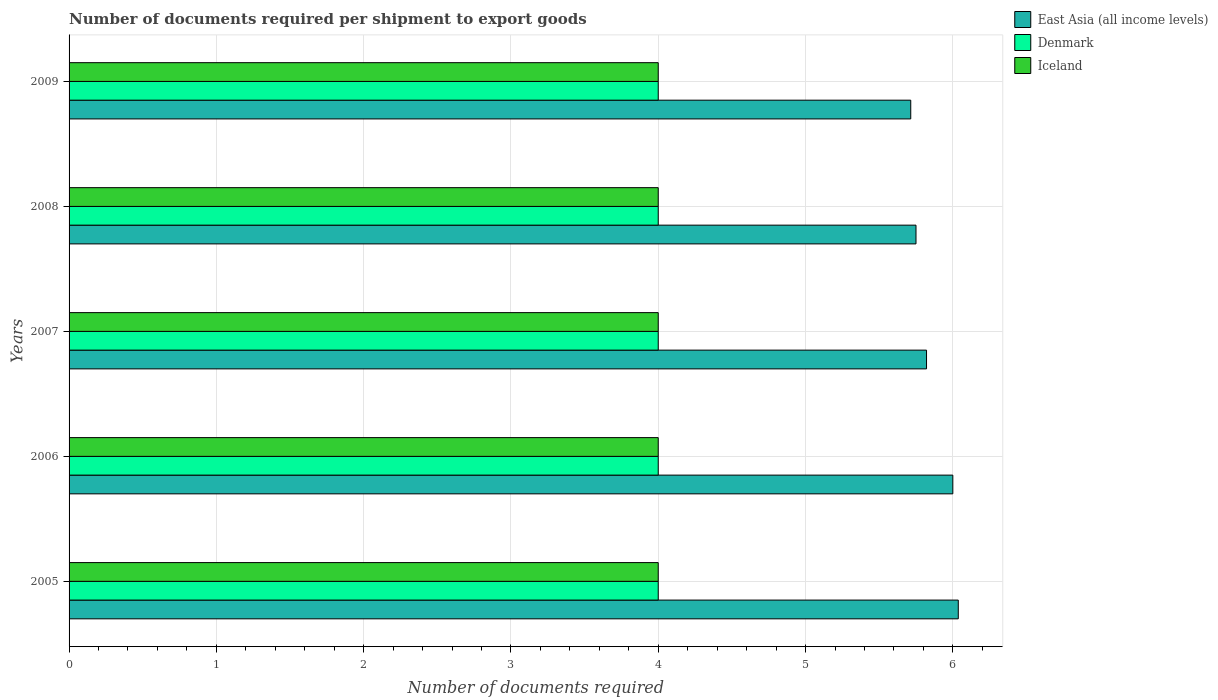How many different coloured bars are there?
Your answer should be compact. 3. How many bars are there on the 4th tick from the bottom?
Your answer should be very brief. 3. What is the label of the 1st group of bars from the top?
Your answer should be very brief. 2009. What is the number of documents required per shipment to export goods in Denmark in 2006?
Provide a succinct answer. 4. Across all years, what is the maximum number of documents required per shipment to export goods in East Asia (all income levels)?
Offer a terse response. 6.04. Across all years, what is the minimum number of documents required per shipment to export goods in Denmark?
Provide a succinct answer. 4. What is the total number of documents required per shipment to export goods in Denmark in the graph?
Make the answer very short. 20. In the year 2008, what is the difference between the number of documents required per shipment to export goods in Iceland and number of documents required per shipment to export goods in East Asia (all income levels)?
Your answer should be very brief. -1.75. What is the ratio of the number of documents required per shipment to export goods in Iceland in 2006 to that in 2008?
Keep it short and to the point. 1. Is the number of documents required per shipment to export goods in Denmark in 2006 less than that in 2008?
Give a very brief answer. No. Is the difference between the number of documents required per shipment to export goods in Iceland in 2005 and 2007 greater than the difference between the number of documents required per shipment to export goods in East Asia (all income levels) in 2005 and 2007?
Your answer should be very brief. No. What is the difference between the highest and the second highest number of documents required per shipment to export goods in Denmark?
Your answer should be compact. 0. What is the difference between the highest and the lowest number of documents required per shipment to export goods in East Asia (all income levels)?
Keep it short and to the point. 0.32. In how many years, is the number of documents required per shipment to export goods in Denmark greater than the average number of documents required per shipment to export goods in Denmark taken over all years?
Ensure brevity in your answer.  0. What does the 2nd bar from the top in 2006 represents?
Offer a terse response. Denmark. What does the 3rd bar from the bottom in 2006 represents?
Keep it short and to the point. Iceland. Is it the case that in every year, the sum of the number of documents required per shipment to export goods in Iceland and number of documents required per shipment to export goods in Denmark is greater than the number of documents required per shipment to export goods in East Asia (all income levels)?
Your answer should be compact. Yes. What is the difference between two consecutive major ticks on the X-axis?
Provide a succinct answer. 1. Does the graph contain any zero values?
Give a very brief answer. No. Where does the legend appear in the graph?
Keep it short and to the point. Top right. What is the title of the graph?
Your answer should be compact. Number of documents required per shipment to export goods. What is the label or title of the X-axis?
Offer a terse response. Number of documents required. What is the Number of documents required in East Asia (all income levels) in 2005?
Make the answer very short. 6.04. What is the Number of documents required in Denmark in 2005?
Keep it short and to the point. 4. What is the Number of documents required in Iceland in 2005?
Keep it short and to the point. 4. What is the Number of documents required of Iceland in 2006?
Offer a terse response. 4. What is the Number of documents required of East Asia (all income levels) in 2007?
Offer a very short reply. 5.82. What is the Number of documents required of Denmark in 2007?
Ensure brevity in your answer.  4. What is the Number of documents required in Iceland in 2007?
Give a very brief answer. 4. What is the Number of documents required in East Asia (all income levels) in 2008?
Offer a terse response. 5.75. What is the Number of documents required in Denmark in 2008?
Keep it short and to the point. 4. What is the Number of documents required of Iceland in 2008?
Make the answer very short. 4. What is the Number of documents required of East Asia (all income levels) in 2009?
Offer a very short reply. 5.71. What is the Number of documents required of Denmark in 2009?
Provide a succinct answer. 4. Across all years, what is the maximum Number of documents required of East Asia (all income levels)?
Your answer should be very brief. 6.04. Across all years, what is the maximum Number of documents required of Iceland?
Your response must be concise. 4. Across all years, what is the minimum Number of documents required of East Asia (all income levels)?
Give a very brief answer. 5.71. Across all years, what is the minimum Number of documents required of Denmark?
Give a very brief answer. 4. What is the total Number of documents required in East Asia (all income levels) in the graph?
Your response must be concise. 29.32. What is the total Number of documents required of Denmark in the graph?
Ensure brevity in your answer.  20. What is the difference between the Number of documents required of East Asia (all income levels) in 2005 and that in 2006?
Your answer should be compact. 0.04. What is the difference between the Number of documents required of Iceland in 2005 and that in 2006?
Keep it short and to the point. 0. What is the difference between the Number of documents required in East Asia (all income levels) in 2005 and that in 2007?
Ensure brevity in your answer.  0.22. What is the difference between the Number of documents required of East Asia (all income levels) in 2005 and that in 2008?
Ensure brevity in your answer.  0.29. What is the difference between the Number of documents required of Iceland in 2005 and that in 2008?
Offer a very short reply. 0. What is the difference between the Number of documents required of East Asia (all income levels) in 2005 and that in 2009?
Provide a succinct answer. 0.32. What is the difference between the Number of documents required of Iceland in 2005 and that in 2009?
Keep it short and to the point. 0. What is the difference between the Number of documents required in East Asia (all income levels) in 2006 and that in 2007?
Provide a succinct answer. 0.18. What is the difference between the Number of documents required in Denmark in 2006 and that in 2007?
Keep it short and to the point. 0. What is the difference between the Number of documents required of Iceland in 2006 and that in 2007?
Provide a short and direct response. 0. What is the difference between the Number of documents required of East Asia (all income levels) in 2006 and that in 2009?
Keep it short and to the point. 0.29. What is the difference between the Number of documents required of East Asia (all income levels) in 2007 and that in 2008?
Your answer should be very brief. 0.07. What is the difference between the Number of documents required of Iceland in 2007 and that in 2008?
Offer a very short reply. 0. What is the difference between the Number of documents required in East Asia (all income levels) in 2007 and that in 2009?
Make the answer very short. 0.11. What is the difference between the Number of documents required of Denmark in 2007 and that in 2009?
Your answer should be compact. 0. What is the difference between the Number of documents required of East Asia (all income levels) in 2008 and that in 2009?
Offer a terse response. 0.04. What is the difference between the Number of documents required of Denmark in 2008 and that in 2009?
Ensure brevity in your answer.  0. What is the difference between the Number of documents required in East Asia (all income levels) in 2005 and the Number of documents required in Denmark in 2006?
Your answer should be very brief. 2.04. What is the difference between the Number of documents required of East Asia (all income levels) in 2005 and the Number of documents required of Iceland in 2006?
Provide a succinct answer. 2.04. What is the difference between the Number of documents required in Denmark in 2005 and the Number of documents required in Iceland in 2006?
Provide a short and direct response. 0. What is the difference between the Number of documents required of East Asia (all income levels) in 2005 and the Number of documents required of Denmark in 2007?
Provide a succinct answer. 2.04. What is the difference between the Number of documents required in East Asia (all income levels) in 2005 and the Number of documents required in Iceland in 2007?
Offer a terse response. 2.04. What is the difference between the Number of documents required of East Asia (all income levels) in 2005 and the Number of documents required of Denmark in 2008?
Offer a terse response. 2.04. What is the difference between the Number of documents required in East Asia (all income levels) in 2005 and the Number of documents required in Iceland in 2008?
Make the answer very short. 2.04. What is the difference between the Number of documents required of Denmark in 2005 and the Number of documents required of Iceland in 2008?
Provide a short and direct response. 0. What is the difference between the Number of documents required in East Asia (all income levels) in 2005 and the Number of documents required in Denmark in 2009?
Your response must be concise. 2.04. What is the difference between the Number of documents required in East Asia (all income levels) in 2005 and the Number of documents required in Iceland in 2009?
Ensure brevity in your answer.  2.04. What is the difference between the Number of documents required of East Asia (all income levels) in 2006 and the Number of documents required of Iceland in 2007?
Ensure brevity in your answer.  2. What is the difference between the Number of documents required in Denmark in 2006 and the Number of documents required in Iceland in 2007?
Your response must be concise. 0. What is the difference between the Number of documents required in East Asia (all income levels) in 2006 and the Number of documents required in Denmark in 2008?
Offer a terse response. 2. What is the difference between the Number of documents required of East Asia (all income levels) in 2006 and the Number of documents required of Denmark in 2009?
Ensure brevity in your answer.  2. What is the difference between the Number of documents required of East Asia (all income levels) in 2006 and the Number of documents required of Iceland in 2009?
Your response must be concise. 2. What is the difference between the Number of documents required of East Asia (all income levels) in 2007 and the Number of documents required of Denmark in 2008?
Give a very brief answer. 1.82. What is the difference between the Number of documents required in East Asia (all income levels) in 2007 and the Number of documents required in Iceland in 2008?
Offer a terse response. 1.82. What is the difference between the Number of documents required of East Asia (all income levels) in 2007 and the Number of documents required of Denmark in 2009?
Your response must be concise. 1.82. What is the difference between the Number of documents required of East Asia (all income levels) in 2007 and the Number of documents required of Iceland in 2009?
Your answer should be compact. 1.82. What is the difference between the Number of documents required of East Asia (all income levels) in 2008 and the Number of documents required of Denmark in 2009?
Provide a short and direct response. 1.75. What is the difference between the Number of documents required of Denmark in 2008 and the Number of documents required of Iceland in 2009?
Ensure brevity in your answer.  0. What is the average Number of documents required in East Asia (all income levels) per year?
Provide a short and direct response. 5.86. What is the average Number of documents required in Denmark per year?
Provide a short and direct response. 4. In the year 2005, what is the difference between the Number of documents required in East Asia (all income levels) and Number of documents required in Denmark?
Your answer should be compact. 2.04. In the year 2005, what is the difference between the Number of documents required in East Asia (all income levels) and Number of documents required in Iceland?
Keep it short and to the point. 2.04. In the year 2005, what is the difference between the Number of documents required in Denmark and Number of documents required in Iceland?
Give a very brief answer. 0. In the year 2006, what is the difference between the Number of documents required of East Asia (all income levels) and Number of documents required of Denmark?
Keep it short and to the point. 2. In the year 2006, what is the difference between the Number of documents required of Denmark and Number of documents required of Iceland?
Make the answer very short. 0. In the year 2007, what is the difference between the Number of documents required in East Asia (all income levels) and Number of documents required in Denmark?
Provide a short and direct response. 1.82. In the year 2007, what is the difference between the Number of documents required in East Asia (all income levels) and Number of documents required in Iceland?
Give a very brief answer. 1.82. In the year 2008, what is the difference between the Number of documents required of East Asia (all income levels) and Number of documents required of Iceland?
Make the answer very short. 1.75. In the year 2008, what is the difference between the Number of documents required in Denmark and Number of documents required in Iceland?
Keep it short and to the point. 0. In the year 2009, what is the difference between the Number of documents required of East Asia (all income levels) and Number of documents required of Denmark?
Your response must be concise. 1.71. In the year 2009, what is the difference between the Number of documents required of East Asia (all income levels) and Number of documents required of Iceland?
Your response must be concise. 1.71. In the year 2009, what is the difference between the Number of documents required in Denmark and Number of documents required in Iceland?
Provide a succinct answer. 0. What is the ratio of the Number of documents required in East Asia (all income levels) in 2005 to that in 2006?
Your answer should be very brief. 1.01. What is the ratio of the Number of documents required of Denmark in 2005 to that in 2006?
Ensure brevity in your answer.  1. What is the ratio of the Number of documents required of East Asia (all income levels) in 2005 to that in 2008?
Give a very brief answer. 1.05. What is the ratio of the Number of documents required in East Asia (all income levels) in 2005 to that in 2009?
Your answer should be very brief. 1.06. What is the ratio of the Number of documents required of Denmark in 2005 to that in 2009?
Offer a very short reply. 1. What is the ratio of the Number of documents required of Iceland in 2005 to that in 2009?
Provide a succinct answer. 1. What is the ratio of the Number of documents required in East Asia (all income levels) in 2006 to that in 2007?
Keep it short and to the point. 1.03. What is the ratio of the Number of documents required of Iceland in 2006 to that in 2007?
Your response must be concise. 1. What is the ratio of the Number of documents required in East Asia (all income levels) in 2006 to that in 2008?
Provide a short and direct response. 1.04. What is the ratio of the Number of documents required in Denmark in 2006 to that in 2008?
Provide a short and direct response. 1. What is the ratio of the Number of documents required of East Asia (all income levels) in 2007 to that in 2008?
Provide a short and direct response. 1.01. What is the ratio of the Number of documents required of Iceland in 2007 to that in 2008?
Offer a terse response. 1. What is the ratio of the Number of documents required of East Asia (all income levels) in 2007 to that in 2009?
Ensure brevity in your answer.  1.02. What is the ratio of the Number of documents required of Denmark in 2007 to that in 2009?
Provide a succinct answer. 1. What is the ratio of the Number of documents required in East Asia (all income levels) in 2008 to that in 2009?
Ensure brevity in your answer.  1.01. What is the difference between the highest and the second highest Number of documents required of East Asia (all income levels)?
Offer a very short reply. 0.04. What is the difference between the highest and the second highest Number of documents required in Denmark?
Your answer should be very brief. 0. What is the difference between the highest and the lowest Number of documents required of East Asia (all income levels)?
Provide a short and direct response. 0.32. 